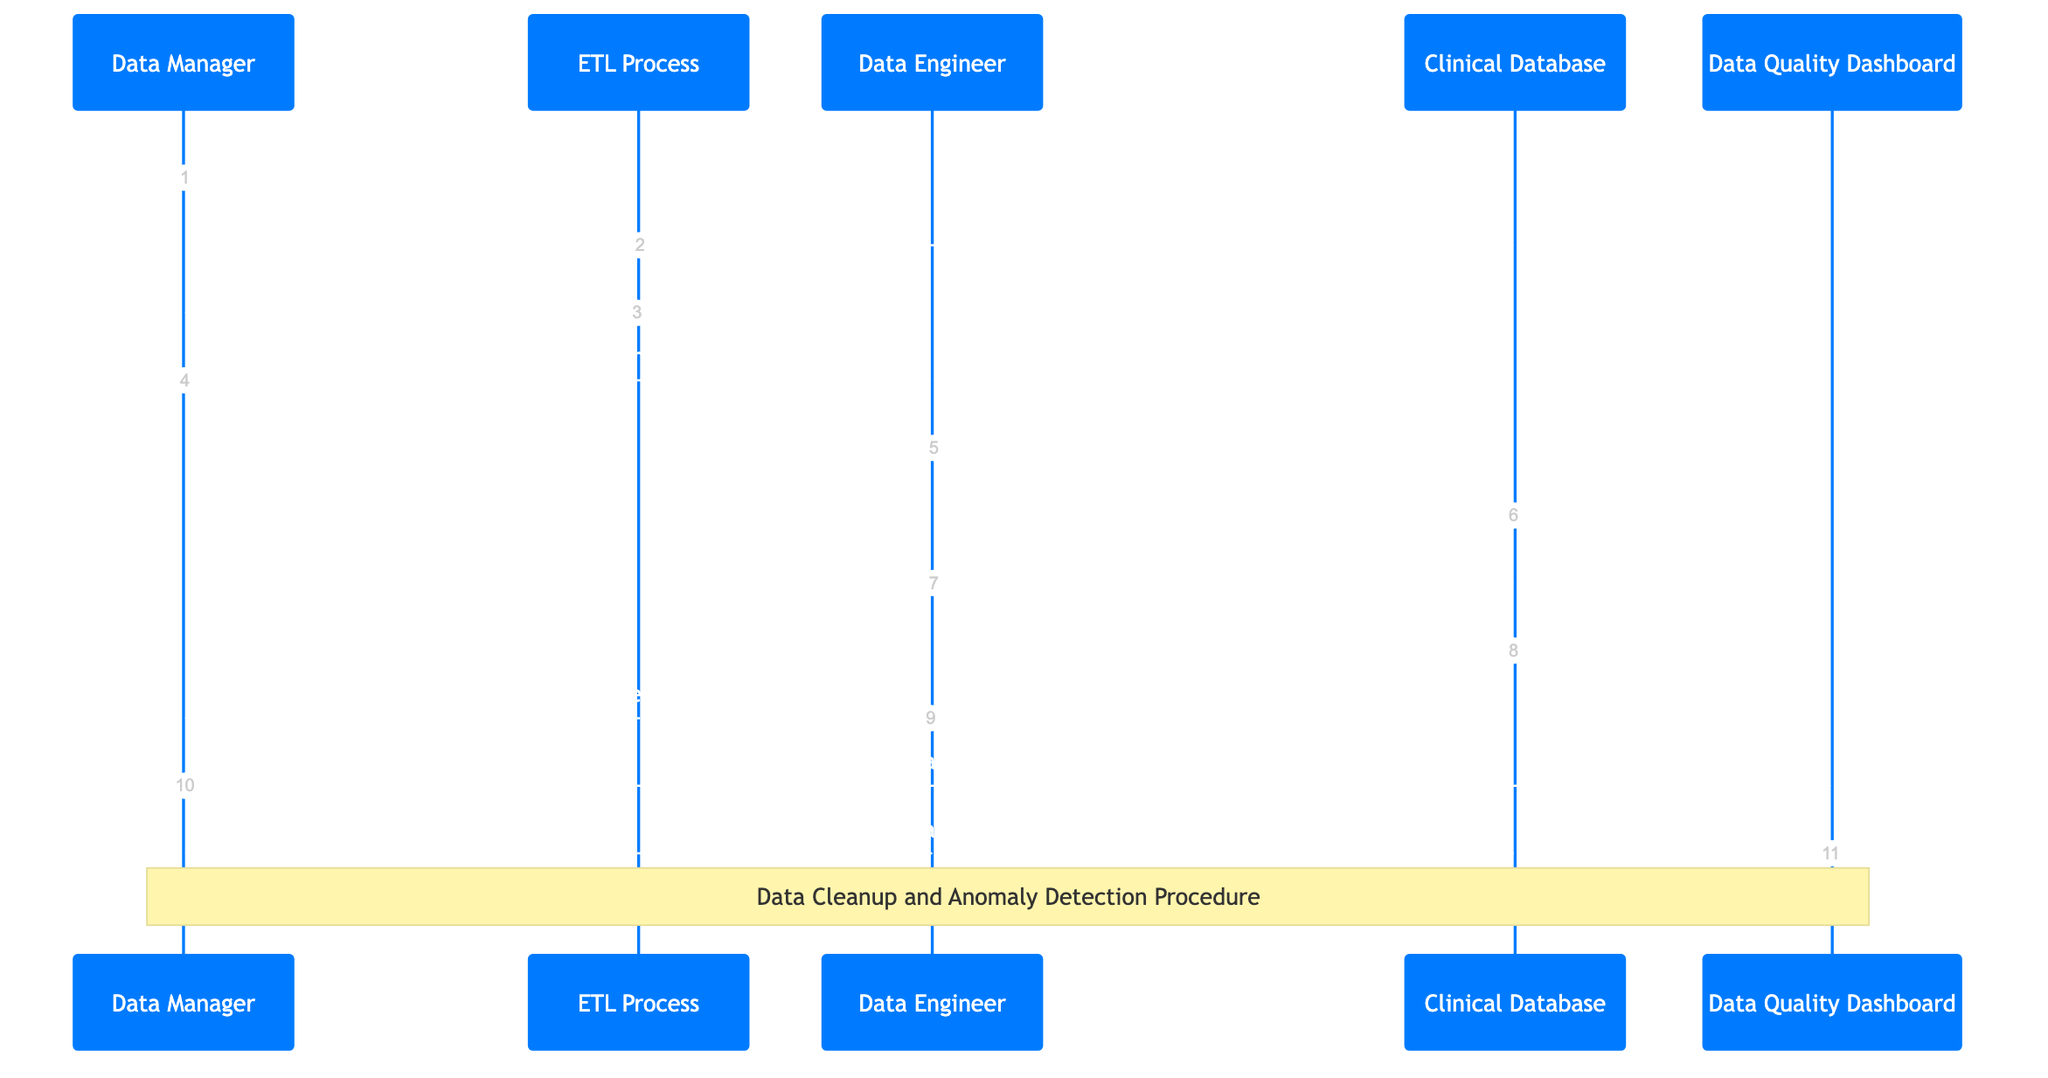What is the first message in the sequence diagram? The first message in the sequence diagram is initiated by the Data Manager to the ETL Process to "Initiate data extraction".
Answer: Initiate data extraction How many actors are present in the diagram? The diagram includes five actors: Data Manager, ETL Process, Data Engineer, Clinical Database, and Data Quality Dashboard.
Answer: Five Who does the Data Engineer send the message "Cleanup and mark anomalies" to? The Data Engineer sends the message "Cleanup and mark anomalies" to the Clinical Database, indicating the action is directed at that actor.
Answer: Clinical Database What is the final action taken by the Data Manager? The final action taken by the Data Manager is to update the Data Quality Dashboard with the latest quality metrics.
Answer: Update dashboard with latest quality metrics Which actor confirms that the cleanup and anomaly detection are completed? The Clinical Database confirms the completion of cleanup and anomaly detection by sending a message back to the Data Engineer.
Answer: Clinical Database How many messages are exchanged between the Data Manager and the Data Engineer? There are two messages exchanged: one where the Data Manager initiates the data cleanup, and the second when the Data Engineer reports completion.
Answer: Two What does the Data Quality Dashboard respond after being updated? The Data Quality Dashboard responds with the message "Dashboard updated" to indicate the update was successful.
Answer: Dashboard updated What is the role of the ETL Process in the workflow? The role of the ETL Process is to extract, transform, and load data into the clinical trial database, ensuring data ingestion is handled properly.
Answer: Extracts, transforms and loads data What is noted as the procedure being followed in the diagram? The note over the Data Manager and Data Quality Dashboard indicates that the procedure being followed is "Data Cleanup and Anomaly Detection Procedure".
Answer: Data Cleanup and Anomaly Detection Procedure 